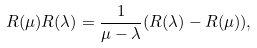Convert formula to latex. <formula><loc_0><loc_0><loc_500><loc_500>R ( \mu ) R ( \lambda ) = \frac { 1 } { \mu - \lambda } ( R ( \lambda ) - R ( \mu ) ) ,</formula> 